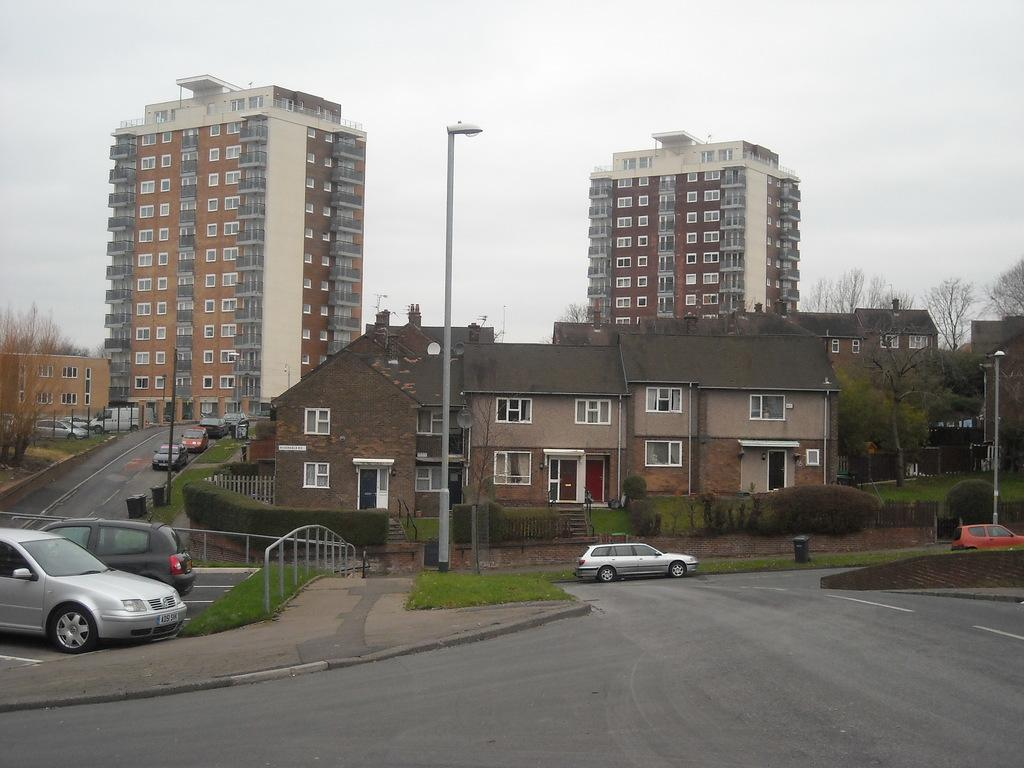What type of pathway can be seen in the image? There is a road in the image. What type of barrier is present alongside the road? There is fencing in the image. What type of vehicles can be seen on the road? There are cars in the image. What type of vegetation is present near the road? There is grass and bushes in the image. What type of structures are present in the image? There are buildings in the image. What type of vertical structures are present in the image? There are poles in the image. What type of tall plants are present in the image? There are trees in the image. What can be seen in the background of the image? The sky is visible in the background of the image. How many kittens are playing on the road in the image? There are no kittens present in the image. What type of journey is depicted in the image? The image does not depict a journey; it shows a road, fencing, cars, grass, bushes, buildings, poles, trees, and the sky. 